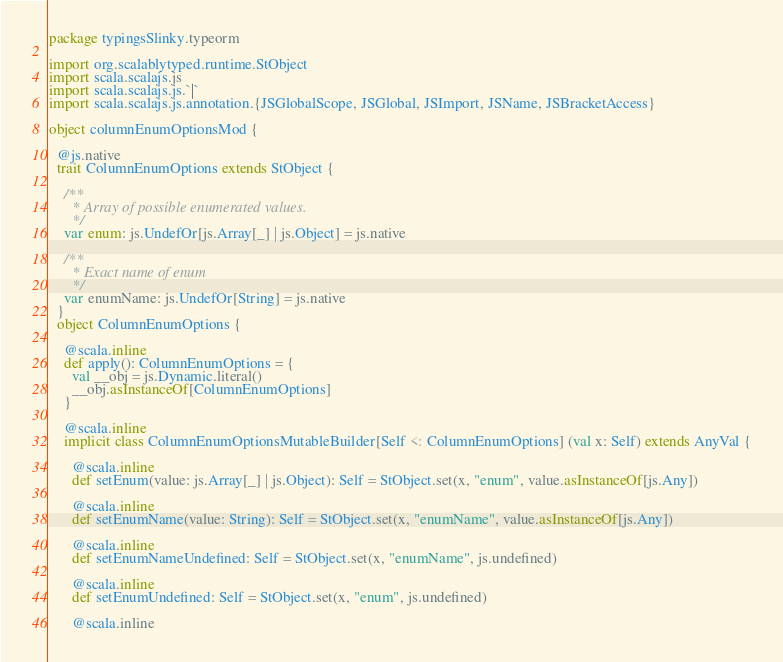<code> <loc_0><loc_0><loc_500><loc_500><_Scala_>package typingsSlinky.typeorm

import org.scalablytyped.runtime.StObject
import scala.scalajs.js
import scala.scalajs.js.`|`
import scala.scalajs.js.annotation.{JSGlobalScope, JSGlobal, JSImport, JSName, JSBracketAccess}

object columnEnumOptionsMod {
  
  @js.native
  trait ColumnEnumOptions extends StObject {
    
    /**
      * Array of possible enumerated values.
      */
    var enum: js.UndefOr[js.Array[_] | js.Object] = js.native
    
    /**
      * Exact name of enum
      */
    var enumName: js.UndefOr[String] = js.native
  }
  object ColumnEnumOptions {
    
    @scala.inline
    def apply(): ColumnEnumOptions = {
      val __obj = js.Dynamic.literal()
      __obj.asInstanceOf[ColumnEnumOptions]
    }
    
    @scala.inline
    implicit class ColumnEnumOptionsMutableBuilder[Self <: ColumnEnumOptions] (val x: Self) extends AnyVal {
      
      @scala.inline
      def setEnum(value: js.Array[_] | js.Object): Self = StObject.set(x, "enum", value.asInstanceOf[js.Any])
      
      @scala.inline
      def setEnumName(value: String): Self = StObject.set(x, "enumName", value.asInstanceOf[js.Any])
      
      @scala.inline
      def setEnumNameUndefined: Self = StObject.set(x, "enumName", js.undefined)
      
      @scala.inline
      def setEnumUndefined: Self = StObject.set(x, "enum", js.undefined)
      
      @scala.inline</code> 